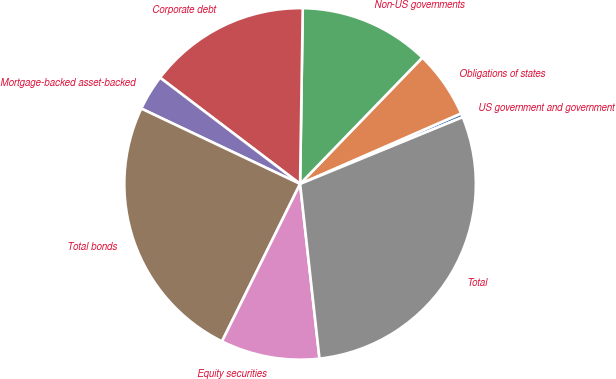<chart> <loc_0><loc_0><loc_500><loc_500><pie_chart><fcel>US government and government<fcel>Obligations of states<fcel>Non-US governments<fcel>Corporate debt<fcel>Mortgage-backed asset-backed<fcel>Total bonds<fcel>Equity securities<fcel>Total<nl><fcel>0.37%<fcel>6.19%<fcel>12.0%<fcel>14.91%<fcel>3.28%<fcel>24.72%<fcel>9.09%<fcel>29.44%<nl></chart> 